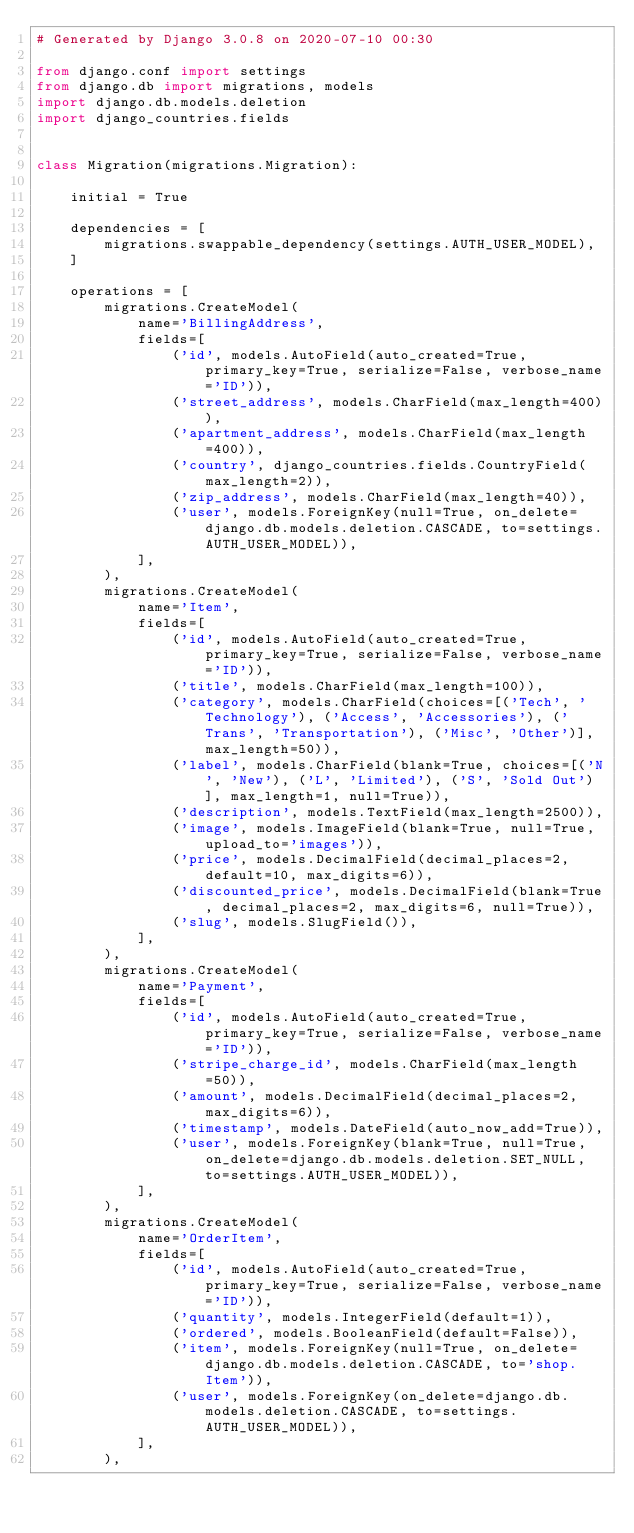Convert code to text. <code><loc_0><loc_0><loc_500><loc_500><_Python_># Generated by Django 3.0.8 on 2020-07-10 00:30

from django.conf import settings
from django.db import migrations, models
import django.db.models.deletion
import django_countries.fields


class Migration(migrations.Migration):

    initial = True

    dependencies = [
        migrations.swappable_dependency(settings.AUTH_USER_MODEL),
    ]

    operations = [
        migrations.CreateModel(
            name='BillingAddress',
            fields=[
                ('id', models.AutoField(auto_created=True, primary_key=True, serialize=False, verbose_name='ID')),
                ('street_address', models.CharField(max_length=400)),
                ('apartment_address', models.CharField(max_length=400)),
                ('country', django_countries.fields.CountryField(max_length=2)),
                ('zip_address', models.CharField(max_length=40)),
                ('user', models.ForeignKey(null=True, on_delete=django.db.models.deletion.CASCADE, to=settings.AUTH_USER_MODEL)),
            ],
        ),
        migrations.CreateModel(
            name='Item',
            fields=[
                ('id', models.AutoField(auto_created=True, primary_key=True, serialize=False, verbose_name='ID')),
                ('title', models.CharField(max_length=100)),
                ('category', models.CharField(choices=[('Tech', 'Technology'), ('Access', 'Accessories'), ('Trans', 'Transportation'), ('Misc', 'Other')], max_length=50)),
                ('label', models.CharField(blank=True, choices=[('N', 'New'), ('L', 'Limited'), ('S', 'Sold Out')], max_length=1, null=True)),
                ('description', models.TextField(max_length=2500)),
                ('image', models.ImageField(blank=True, null=True, upload_to='images')),
                ('price', models.DecimalField(decimal_places=2, default=10, max_digits=6)),
                ('discounted_price', models.DecimalField(blank=True, decimal_places=2, max_digits=6, null=True)),
                ('slug', models.SlugField()),
            ],
        ),
        migrations.CreateModel(
            name='Payment',
            fields=[
                ('id', models.AutoField(auto_created=True, primary_key=True, serialize=False, verbose_name='ID')),
                ('stripe_charge_id', models.CharField(max_length=50)),
                ('amount', models.DecimalField(decimal_places=2, max_digits=6)),
                ('timestamp', models.DateField(auto_now_add=True)),
                ('user', models.ForeignKey(blank=True, null=True, on_delete=django.db.models.deletion.SET_NULL, to=settings.AUTH_USER_MODEL)),
            ],
        ),
        migrations.CreateModel(
            name='OrderItem',
            fields=[
                ('id', models.AutoField(auto_created=True, primary_key=True, serialize=False, verbose_name='ID')),
                ('quantity', models.IntegerField(default=1)),
                ('ordered', models.BooleanField(default=False)),
                ('item', models.ForeignKey(null=True, on_delete=django.db.models.deletion.CASCADE, to='shop.Item')),
                ('user', models.ForeignKey(on_delete=django.db.models.deletion.CASCADE, to=settings.AUTH_USER_MODEL)),
            ],
        ),</code> 